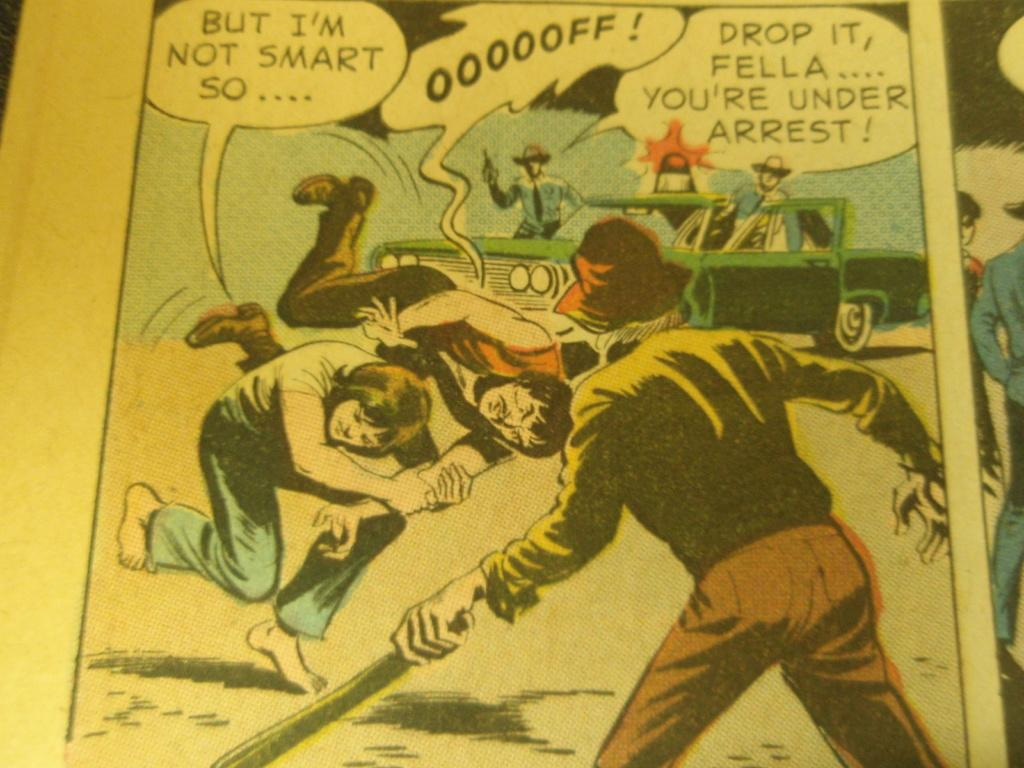Provide a one-sentence caption for the provided image. The person in the comic yells drop it. 